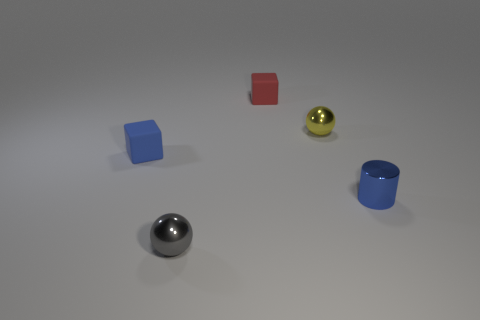Add 2 tiny blue cylinders. How many objects exist? 7 Subtract all red blocks. How many blocks are left? 1 Add 4 small red things. How many small red things exist? 5 Subtract 0 purple cylinders. How many objects are left? 5 Subtract all blocks. How many objects are left? 3 Subtract 1 blocks. How many blocks are left? 1 Subtract all yellow cubes. Subtract all green cylinders. How many cubes are left? 2 Subtract all tiny cyan rubber cubes. Subtract all tiny gray balls. How many objects are left? 4 Add 1 blue matte blocks. How many blue matte blocks are left? 2 